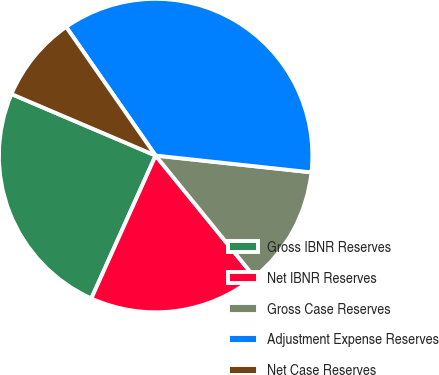Convert chart. <chart><loc_0><loc_0><loc_500><loc_500><pie_chart><fcel>Gross IBNR Reserves<fcel>Net IBNR Reserves<fcel>Gross Case Reserves<fcel>Adjustment Expense Reserves<fcel>Net Case Reserves<nl><fcel>24.69%<fcel>17.6%<fcel>12.42%<fcel>36.38%<fcel>8.91%<nl></chart> 